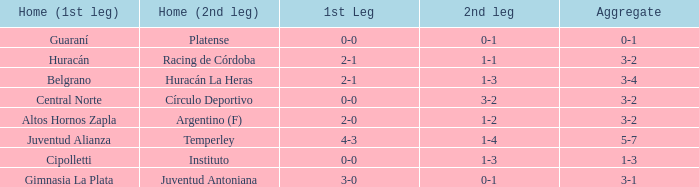Which team had a 1-1 tie in the 2nd leg at home and achieved a 3-2 overall score? Racing de Córdoba. 